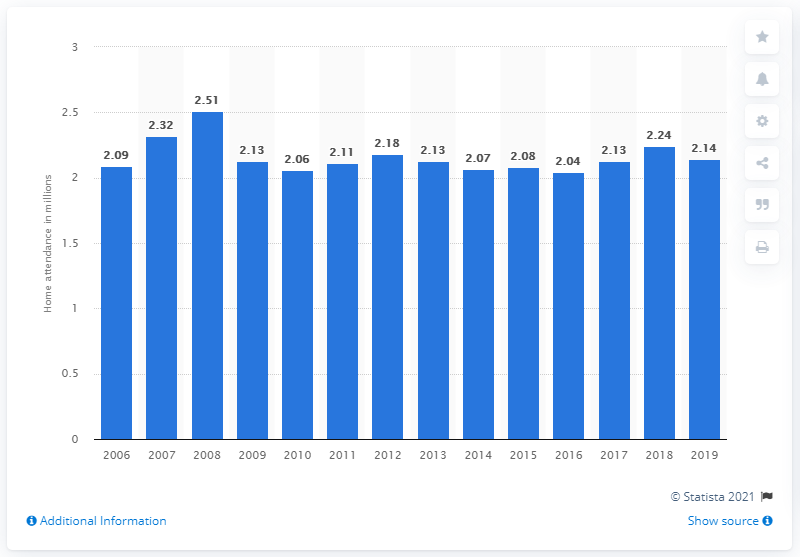Outline some significant characteristics in this image. The average attendance of the Arizona Diamondbacks in 2019 was approximately 2.14 fans per game. 